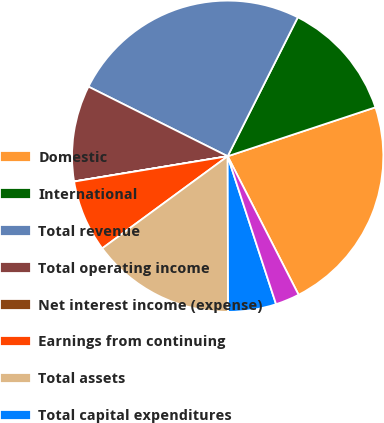Convert chart to OTSL. <chart><loc_0><loc_0><loc_500><loc_500><pie_chart><fcel>Domestic<fcel>International<fcel>Total revenue<fcel>Total operating income<fcel>Net interest income (expense)<fcel>Earnings from continuing<fcel>Total assets<fcel>Total capital expenditures<fcel>Total depreciation<nl><fcel>22.56%<fcel>12.47%<fcel>25.06%<fcel>9.97%<fcel>0.01%<fcel>7.48%<fcel>14.96%<fcel>4.99%<fcel>2.5%<nl></chart> 